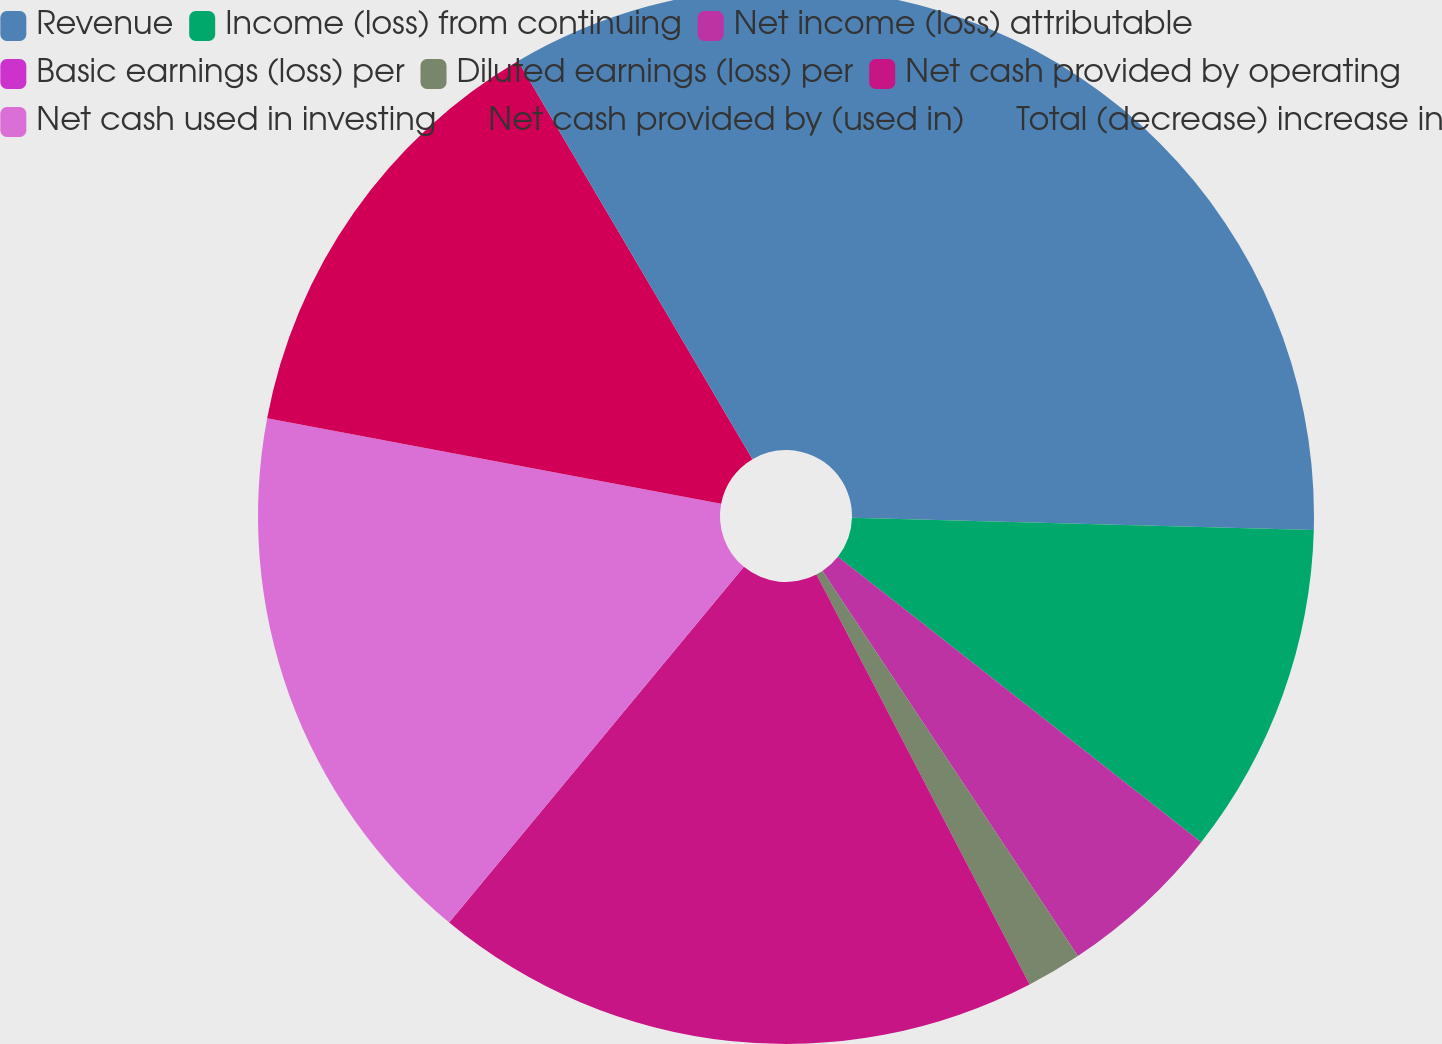Convert chart to OTSL. <chart><loc_0><loc_0><loc_500><loc_500><pie_chart><fcel>Revenue<fcel>Income (loss) from continuing<fcel>Net income (loss) attributable<fcel>Basic earnings (loss) per<fcel>Diluted earnings (loss) per<fcel>Net cash provided by operating<fcel>Net cash used in investing<fcel>Net cash provided by (used in)<fcel>Total (decrease) increase in<nl><fcel>25.42%<fcel>10.17%<fcel>5.08%<fcel>0.0%<fcel>1.69%<fcel>18.64%<fcel>16.95%<fcel>13.56%<fcel>8.47%<nl></chart> 